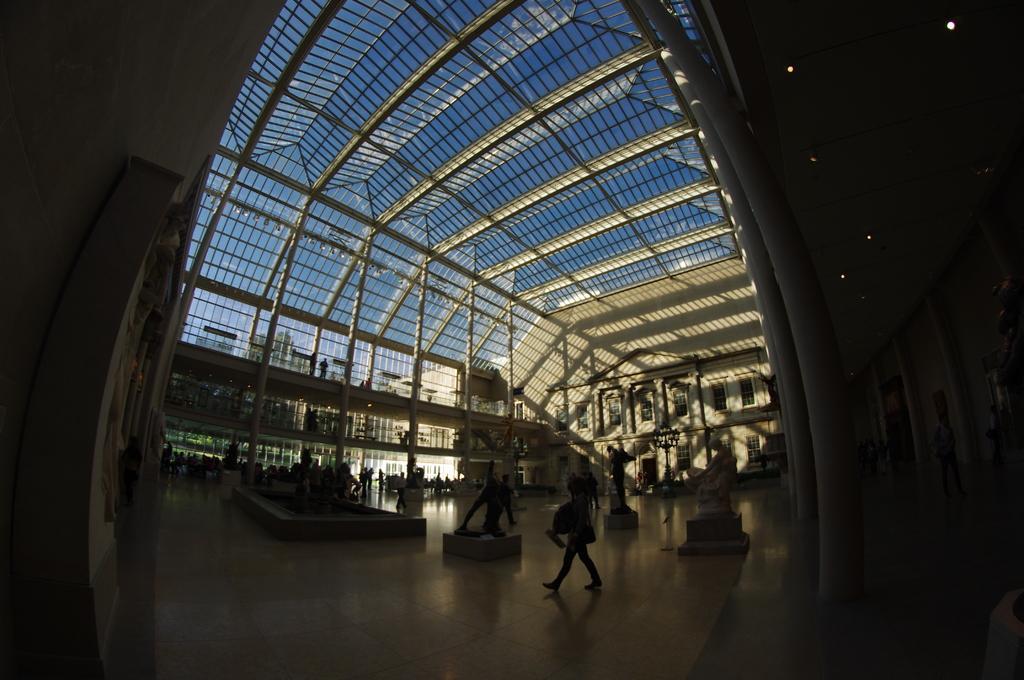Can you describe this image briefly? In this image I can see inside view of a building and I can also see few sculptures and few people. On the top side of the image I can see the sky and on the right side I can see few lights on the ceiling. I can also see this image is little bit in dark. 